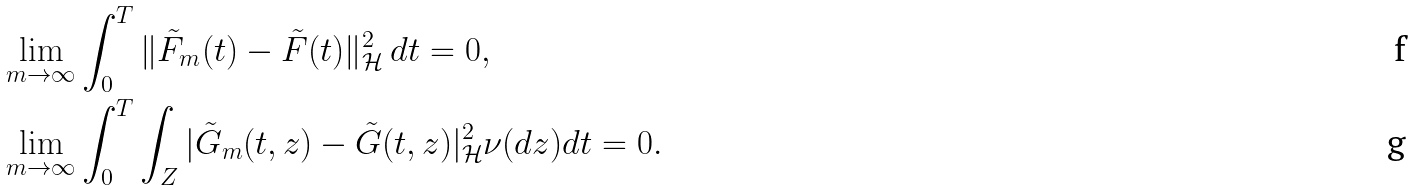Convert formula to latex. <formula><loc_0><loc_0><loc_500><loc_500>& \lim _ { m \rightarrow \infty } \int _ { 0 } ^ { T } \| \tilde { F } _ { m } ( t ) - \tilde { F } ( t ) \| _ { \mathcal { H } } ^ { 2 } \, d t = 0 , \\ & \lim _ { m \rightarrow \infty } \int _ { 0 } ^ { T } \int _ { Z } | \tilde { G } _ { m } ( t , z ) - \tilde { G } ( t , z ) | ^ { 2 } _ { \mathcal { H } } \nu ( d z ) d t = 0 .</formula> 